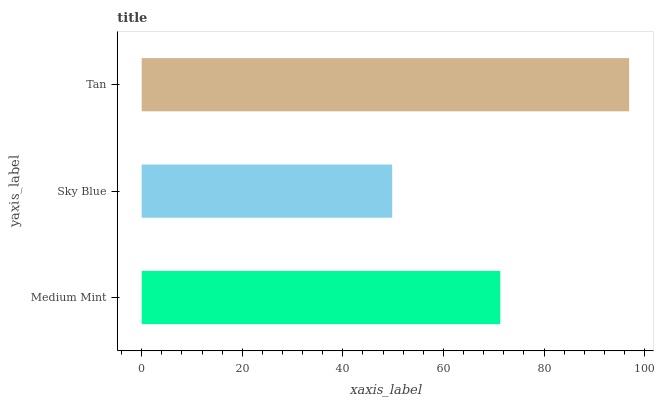Is Sky Blue the minimum?
Answer yes or no. Yes. Is Tan the maximum?
Answer yes or no. Yes. Is Tan the minimum?
Answer yes or no. No. Is Sky Blue the maximum?
Answer yes or no. No. Is Tan greater than Sky Blue?
Answer yes or no. Yes. Is Sky Blue less than Tan?
Answer yes or no. Yes. Is Sky Blue greater than Tan?
Answer yes or no. No. Is Tan less than Sky Blue?
Answer yes or no. No. Is Medium Mint the high median?
Answer yes or no. Yes. Is Medium Mint the low median?
Answer yes or no. Yes. Is Sky Blue the high median?
Answer yes or no. No. Is Sky Blue the low median?
Answer yes or no. No. 